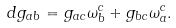Convert formula to latex. <formula><loc_0><loc_0><loc_500><loc_500>d g _ { a b } = g _ { a c } \omega ^ { c } _ { b } + g _ { b c } \omega ^ { c } _ { a } .</formula> 